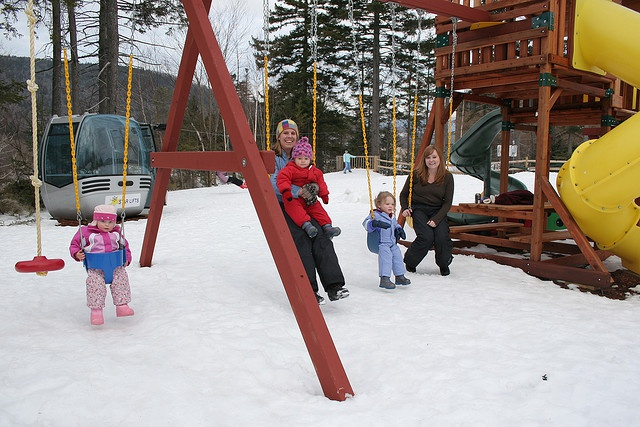Describe the objects in this image and their specific colors. I can see bus in darkgreen, gray, black, darkgray, and purple tones, people in darkgreen, black, maroon, and gray tones, people in darkgreen, darkgray, blue, lightpink, and violet tones, people in darkgreen, brown, maroon, gray, and black tones, and people in darkgreen, darkgray, and gray tones in this image. 